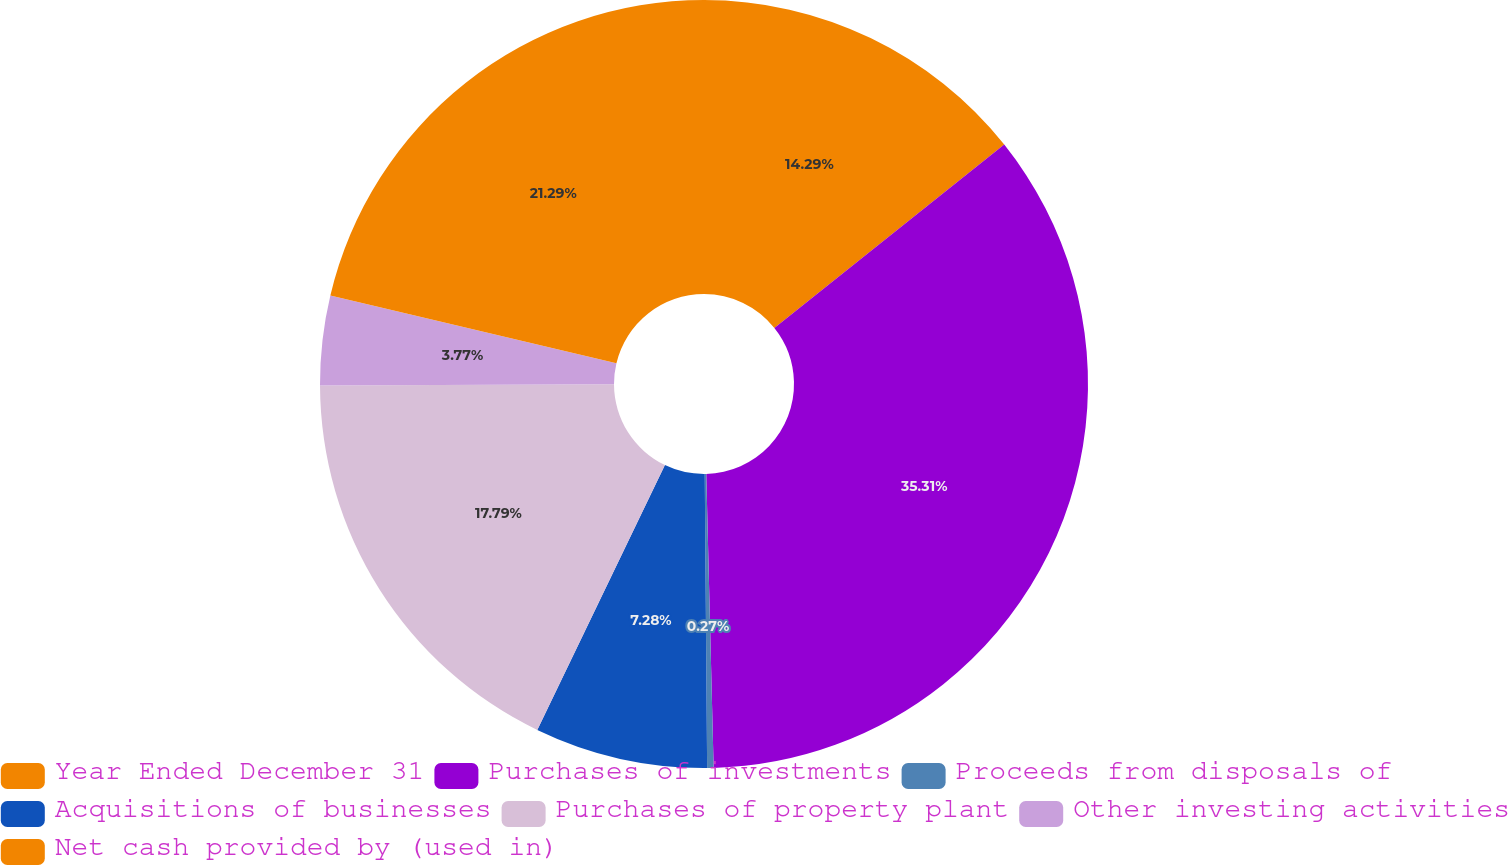Convert chart. <chart><loc_0><loc_0><loc_500><loc_500><pie_chart><fcel>Year Ended December 31<fcel>Purchases of investments<fcel>Proceeds from disposals of<fcel>Acquisitions of businesses<fcel>Purchases of property plant<fcel>Other investing activities<fcel>Net cash provided by (used in)<nl><fcel>14.29%<fcel>35.32%<fcel>0.27%<fcel>7.28%<fcel>17.79%<fcel>3.77%<fcel>21.3%<nl></chart> 